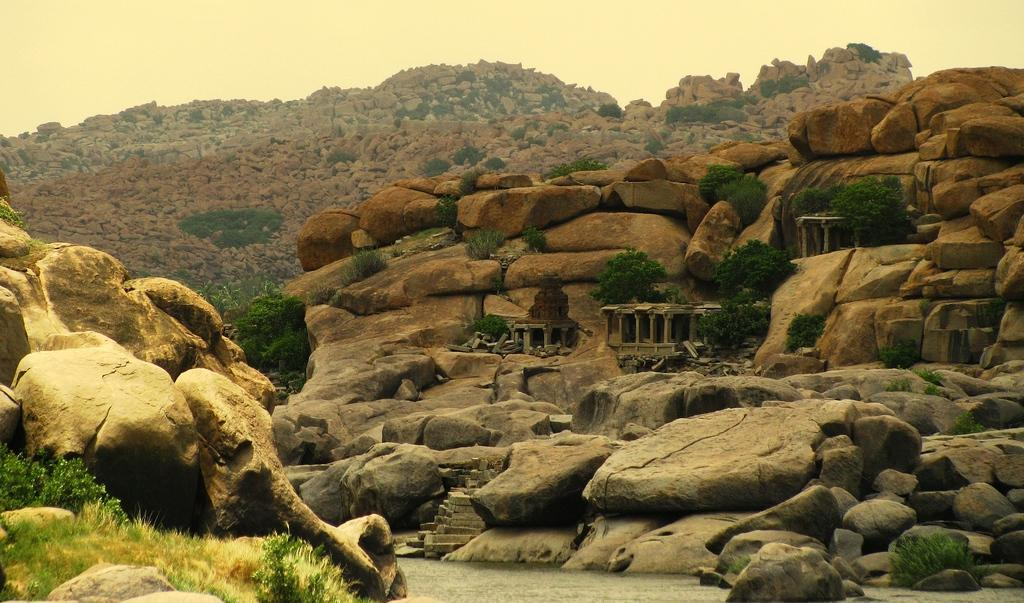What type of natural features can be seen in the image? There are hills and mountains in the image. What else can be found between the hills? There are trees and plants between the hills. How many sisters are sitting on the pot in the image? There is no pot or sisters present in the image. 